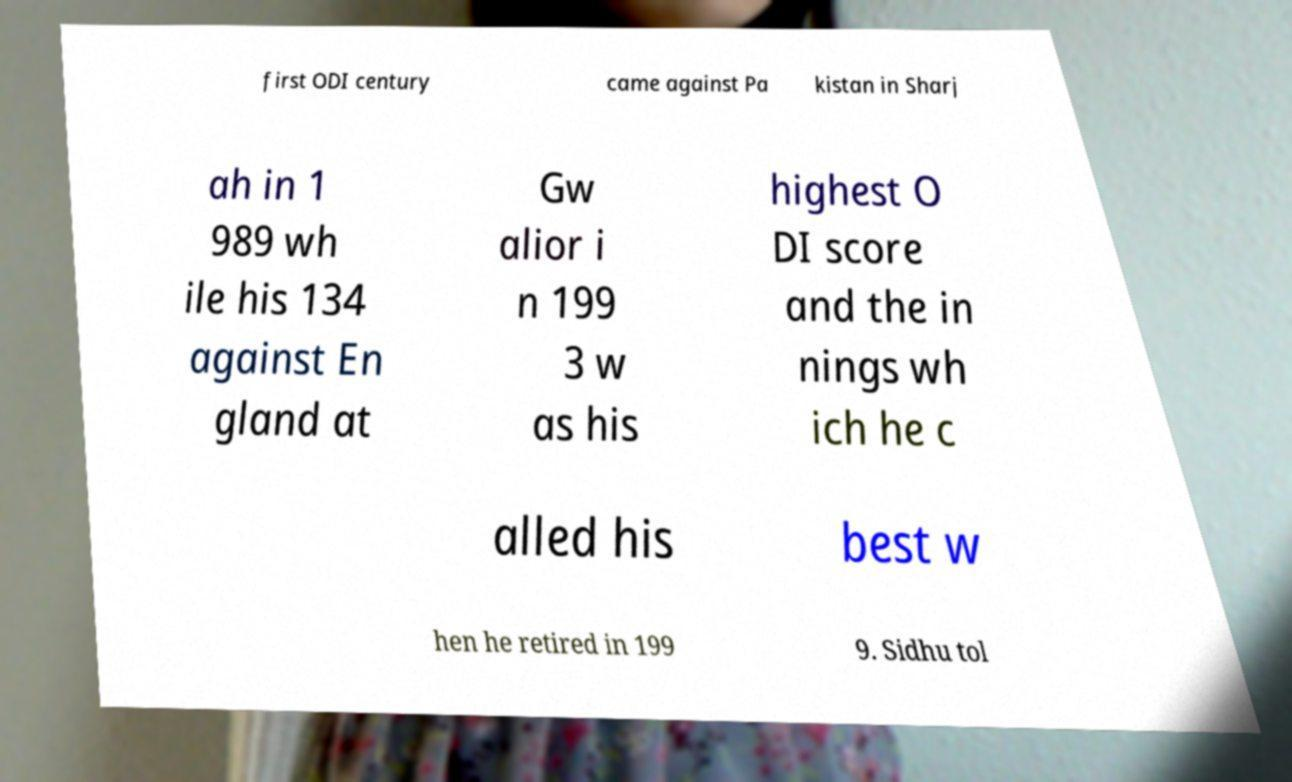Please read and relay the text visible in this image. What does it say? first ODI century came against Pa kistan in Sharj ah in 1 989 wh ile his 134 against En gland at Gw alior i n 199 3 w as his highest O DI score and the in nings wh ich he c alled his best w hen he retired in 199 9. Sidhu tol 